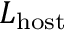Convert formula to latex. <formula><loc_0><loc_0><loc_500><loc_500>L _ { h o s t }</formula> 